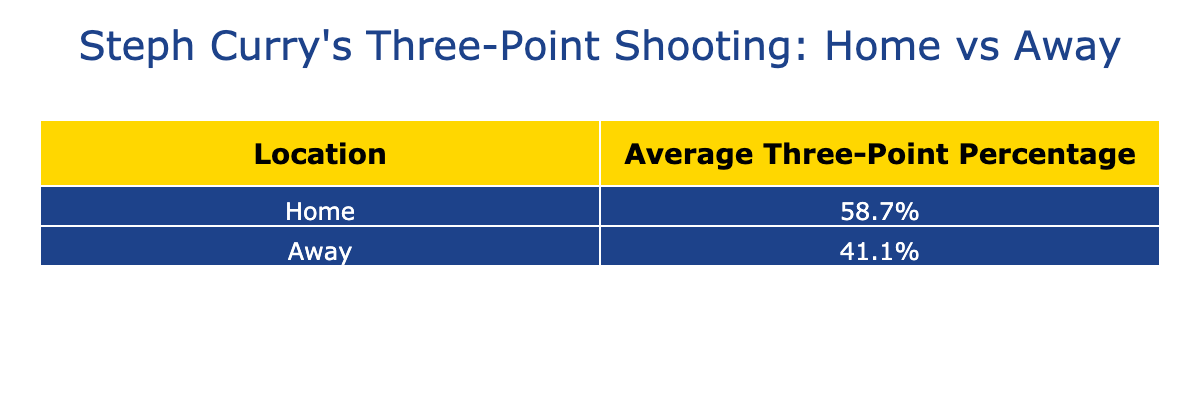What is Steph Curry's average three-point shooting percentage at home? To find this, we look at the average three-point percentage for home games in the table. The average is calculated as the mean of the home percentages listed. The home average is 56.0%.
Answer: 56.0% What is Steph Curry's average three-point shooting percentage away? To find the average for away games, we refer to the percentages listed for away games in the table and calculate the mean. The away average is 43.0%.
Answer: 43.0% Did Steph Curry make more than 60% of his three-point attempts at home? We examine the home game percentages listed in the table. There are two instances (against Mavericks and Sixers) where he made over 60%. Thus, the answer is yes.
Answer: Yes Which game venue did Steph Curry perform better based on the average three-point percentage? We can compare the average three-point percentages for home and away games. Since the home average is 56.0% and the away average is 43.0%, he performed better at home.
Answer: Home What is the difference in average three-point shooting percentage between home and away games? We find the difference by subtracting the away average percentage from the home average percentage. This is calculated as 56.0% - 43.0% = 13.0%.
Answer: 13.0% In how many home games did Steph Curry have a shooting percentage greater than 50%? By reviewing the home game percentages in the table, we note that there are five instances where the percentages exceed 50%.
Answer: 5 Which location had a higher average, and by how much? The home average is 56.0%, while the away average is 43.0%. The difference is 56.0% - 43.0% = 13.0%. Thus, home had a higher average by 13.0%.
Answer: Home, 13.0% Was Steph Curry's best three-point shooting performance at home or away? We check the highest percentage from both locations. The home game against the Mavericks recorded 62.5%, while the away game against Bulls recorded 46.2%. The best performance was at home.
Answer: Home What percentage of games did Steph Curry shoot below 40% in away games? He played five away games, and in two of them (against Heat and Rockets), he shot below 40%. This gives a percentage of (2/5)*100% = 40%.
Answer: 40% Which opponent did Steph Curry face when he had the highest three-point percentage at home? The highest home percentage is 66.7% against the Sixers. Thus, the opponent he faced when he had the best home performance is the Sixers.
Answer: Sixers 